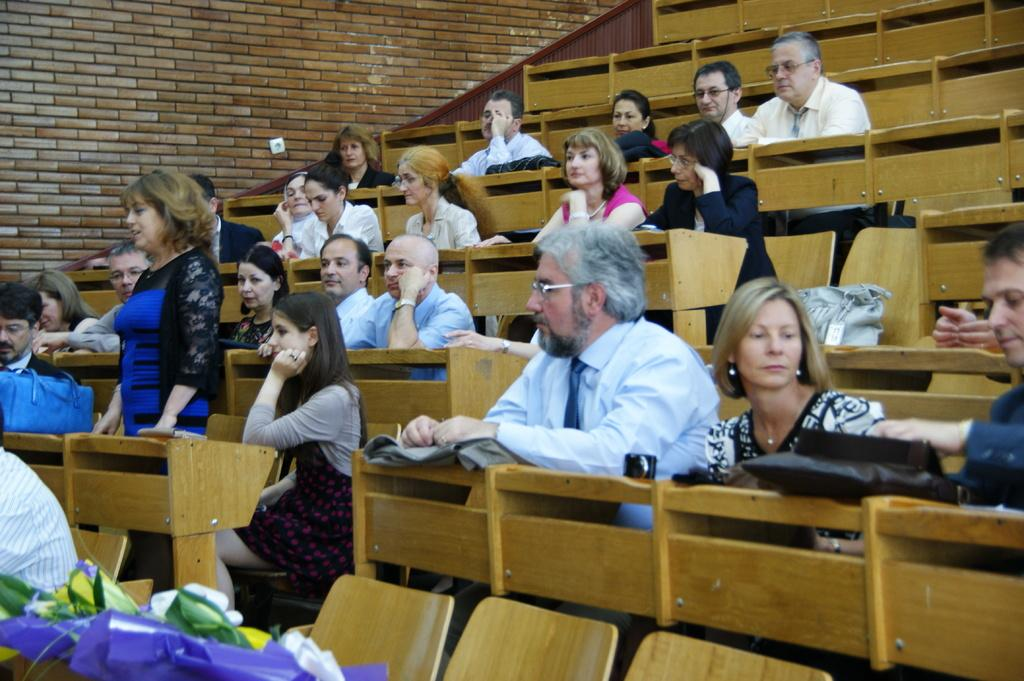How many people are in the image? There is a group of people in the image. What are some of the people in the image doing? Some people are seated, and a woman is standing. What can be seen on the tables in the image? There are bags on the tables in the image. What type of church can be seen in the background of the image? There is no church visible in the image. How much power is being generated by the people in the image? The image does not provide any information about power generation, as it focuses on a group of people and their actions. 